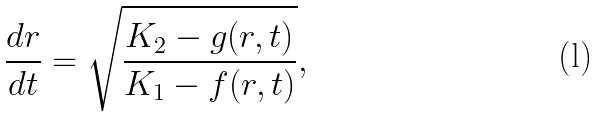<formula> <loc_0><loc_0><loc_500><loc_500>\frac { d r } { d t } = \sqrt { \frac { K _ { 2 } - g ( r , t ) } { K _ { 1 } - f ( r , t ) } } ,</formula> 